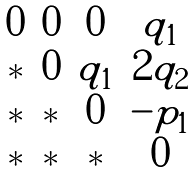<formula> <loc_0><loc_0><loc_500><loc_500>\begin{matrix} 0 & 0 & 0 & q _ { 1 } \\ * & 0 & q _ { 1 } & 2 q _ { 2 } \\ * & * & 0 & - p _ { 1 } \\ * & * & * & 0 \end{matrix}</formula> 